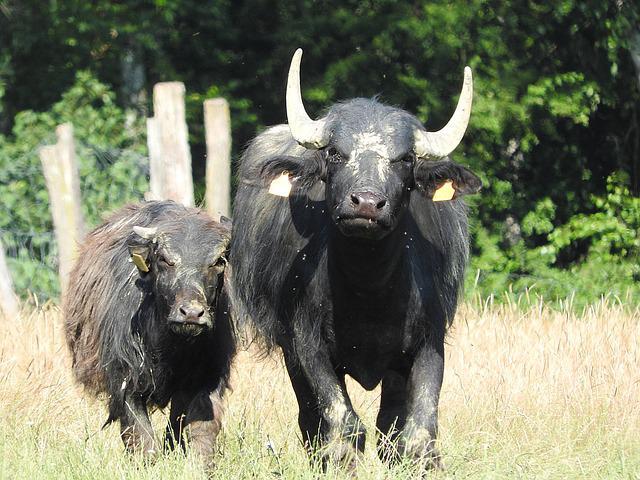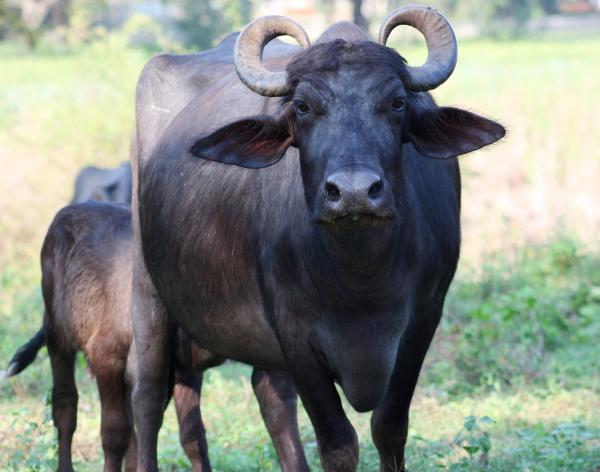The first image is the image on the left, the second image is the image on the right. Given the left and right images, does the statement "No other animal is pictured except for two bulls." hold true? Answer yes or no. No. 